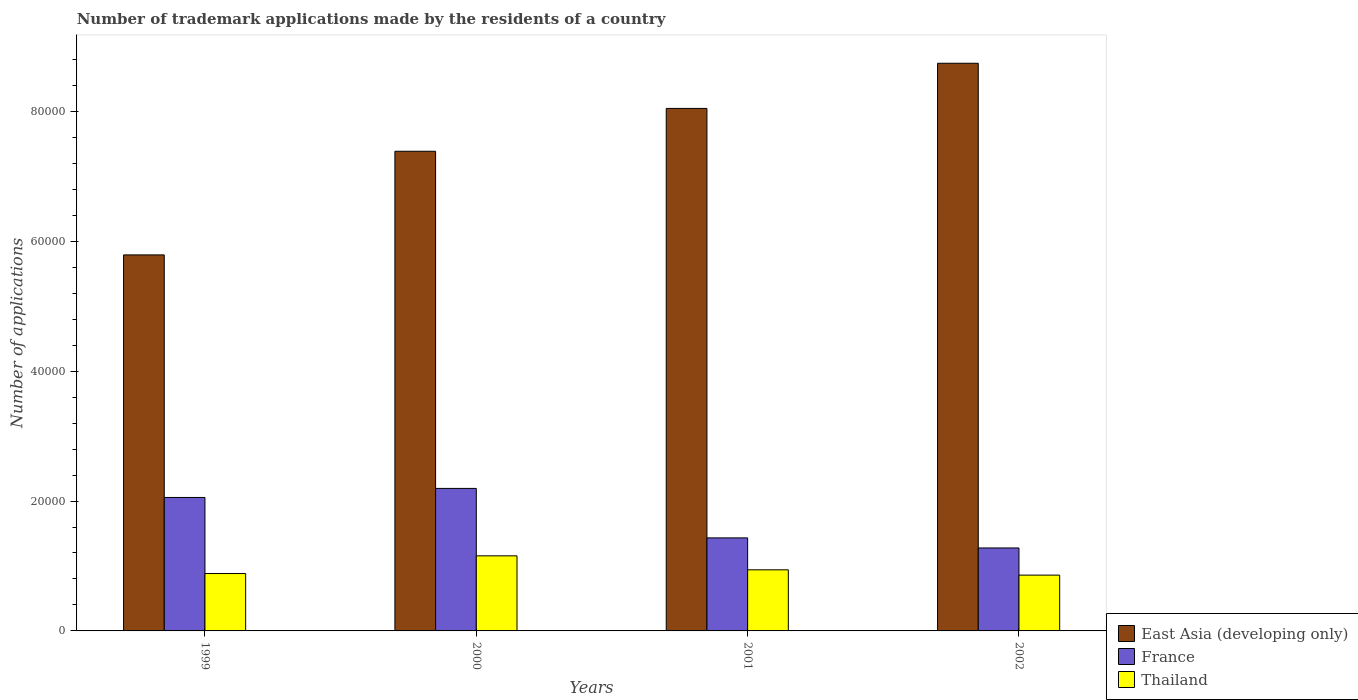How many different coloured bars are there?
Keep it short and to the point. 3. How many groups of bars are there?
Keep it short and to the point. 4. Are the number of bars per tick equal to the number of legend labels?
Ensure brevity in your answer.  Yes. How many bars are there on the 4th tick from the left?
Your answer should be very brief. 3. What is the number of trademark applications made by the residents in East Asia (developing only) in 2002?
Keep it short and to the point. 8.74e+04. Across all years, what is the maximum number of trademark applications made by the residents in East Asia (developing only)?
Offer a terse response. 8.74e+04. Across all years, what is the minimum number of trademark applications made by the residents in Thailand?
Keep it short and to the point. 8591. In which year was the number of trademark applications made by the residents in France maximum?
Offer a terse response. 2000. In which year was the number of trademark applications made by the residents in France minimum?
Ensure brevity in your answer.  2002. What is the total number of trademark applications made by the residents in France in the graph?
Your answer should be very brief. 6.96e+04. What is the difference between the number of trademark applications made by the residents in France in 1999 and that in 2001?
Ensure brevity in your answer.  6226. What is the difference between the number of trademark applications made by the residents in East Asia (developing only) in 2001 and the number of trademark applications made by the residents in France in 2002?
Your response must be concise. 6.77e+04. What is the average number of trademark applications made by the residents in Thailand per year?
Ensure brevity in your answer.  9599. In the year 2000, what is the difference between the number of trademark applications made by the residents in France and number of trademark applications made by the residents in Thailand?
Provide a short and direct response. 1.04e+04. What is the ratio of the number of trademark applications made by the residents in France in 2000 to that in 2002?
Your answer should be compact. 1.72. Is the number of trademark applications made by the residents in East Asia (developing only) in 1999 less than that in 2000?
Give a very brief answer. Yes. What is the difference between the highest and the second highest number of trademark applications made by the residents in France?
Offer a terse response. 1392. What is the difference between the highest and the lowest number of trademark applications made by the residents in East Asia (developing only)?
Give a very brief answer. 2.95e+04. In how many years, is the number of trademark applications made by the residents in Thailand greater than the average number of trademark applications made by the residents in Thailand taken over all years?
Ensure brevity in your answer.  1. Is the sum of the number of trademark applications made by the residents in France in 1999 and 2000 greater than the maximum number of trademark applications made by the residents in Thailand across all years?
Keep it short and to the point. Yes. What does the 1st bar from the left in 2002 represents?
Provide a short and direct response. East Asia (developing only). What does the 3rd bar from the right in 2002 represents?
Offer a very short reply. East Asia (developing only). How many bars are there?
Offer a very short reply. 12. Are all the bars in the graph horizontal?
Keep it short and to the point. No. How many years are there in the graph?
Provide a short and direct response. 4. How are the legend labels stacked?
Keep it short and to the point. Vertical. What is the title of the graph?
Give a very brief answer. Number of trademark applications made by the residents of a country. What is the label or title of the Y-axis?
Your answer should be compact. Number of applications. What is the Number of applications of East Asia (developing only) in 1999?
Offer a terse response. 5.79e+04. What is the Number of applications in France in 1999?
Give a very brief answer. 2.06e+04. What is the Number of applications in Thailand in 1999?
Give a very brief answer. 8838. What is the Number of applications of East Asia (developing only) in 2000?
Your response must be concise. 7.39e+04. What is the Number of applications of France in 2000?
Provide a succinct answer. 2.19e+04. What is the Number of applications of Thailand in 2000?
Offer a very short reply. 1.16e+04. What is the Number of applications of East Asia (developing only) in 2001?
Your response must be concise. 8.05e+04. What is the Number of applications of France in 2001?
Provide a short and direct response. 1.43e+04. What is the Number of applications of Thailand in 2001?
Keep it short and to the point. 9407. What is the Number of applications of East Asia (developing only) in 2002?
Provide a succinct answer. 8.74e+04. What is the Number of applications of France in 2002?
Provide a succinct answer. 1.28e+04. What is the Number of applications of Thailand in 2002?
Keep it short and to the point. 8591. Across all years, what is the maximum Number of applications of East Asia (developing only)?
Provide a short and direct response. 8.74e+04. Across all years, what is the maximum Number of applications in France?
Offer a terse response. 2.19e+04. Across all years, what is the maximum Number of applications of Thailand?
Offer a terse response. 1.16e+04. Across all years, what is the minimum Number of applications of East Asia (developing only)?
Provide a short and direct response. 5.79e+04. Across all years, what is the minimum Number of applications in France?
Offer a very short reply. 1.28e+04. Across all years, what is the minimum Number of applications in Thailand?
Your answer should be compact. 8591. What is the total Number of applications in East Asia (developing only) in the graph?
Your answer should be very brief. 3.00e+05. What is the total Number of applications of France in the graph?
Provide a succinct answer. 6.96e+04. What is the total Number of applications in Thailand in the graph?
Make the answer very short. 3.84e+04. What is the difference between the Number of applications of East Asia (developing only) in 1999 and that in 2000?
Keep it short and to the point. -1.60e+04. What is the difference between the Number of applications in France in 1999 and that in 2000?
Offer a terse response. -1392. What is the difference between the Number of applications in Thailand in 1999 and that in 2000?
Offer a very short reply. -2722. What is the difference between the Number of applications of East Asia (developing only) in 1999 and that in 2001?
Offer a very short reply. -2.26e+04. What is the difference between the Number of applications of France in 1999 and that in 2001?
Provide a succinct answer. 6226. What is the difference between the Number of applications in Thailand in 1999 and that in 2001?
Ensure brevity in your answer.  -569. What is the difference between the Number of applications in East Asia (developing only) in 1999 and that in 2002?
Keep it short and to the point. -2.95e+04. What is the difference between the Number of applications in France in 1999 and that in 2002?
Make the answer very short. 7776. What is the difference between the Number of applications of Thailand in 1999 and that in 2002?
Your response must be concise. 247. What is the difference between the Number of applications of East Asia (developing only) in 2000 and that in 2001?
Provide a succinct answer. -6597. What is the difference between the Number of applications of France in 2000 and that in 2001?
Keep it short and to the point. 7618. What is the difference between the Number of applications of Thailand in 2000 and that in 2001?
Ensure brevity in your answer.  2153. What is the difference between the Number of applications of East Asia (developing only) in 2000 and that in 2002?
Your answer should be very brief. -1.35e+04. What is the difference between the Number of applications of France in 2000 and that in 2002?
Provide a short and direct response. 9168. What is the difference between the Number of applications in Thailand in 2000 and that in 2002?
Your answer should be compact. 2969. What is the difference between the Number of applications in East Asia (developing only) in 2001 and that in 2002?
Your answer should be compact. -6952. What is the difference between the Number of applications of France in 2001 and that in 2002?
Ensure brevity in your answer.  1550. What is the difference between the Number of applications in Thailand in 2001 and that in 2002?
Your answer should be compact. 816. What is the difference between the Number of applications in East Asia (developing only) in 1999 and the Number of applications in France in 2000?
Provide a short and direct response. 3.60e+04. What is the difference between the Number of applications in East Asia (developing only) in 1999 and the Number of applications in Thailand in 2000?
Your response must be concise. 4.63e+04. What is the difference between the Number of applications in France in 1999 and the Number of applications in Thailand in 2000?
Offer a very short reply. 8990. What is the difference between the Number of applications of East Asia (developing only) in 1999 and the Number of applications of France in 2001?
Provide a short and direct response. 4.36e+04. What is the difference between the Number of applications of East Asia (developing only) in 1999 and the Number of applications of Thailand in 2001?
Your response must be concise. 4.85e+04. What is the difference between the Number of applications in France in 1999 and the Number of applications in Thailand in 2001?
Give a very brief answer. 1.11e+04. What is the difference between the Number of applications of East Asia (developing only) in 1999 and the Number of applications of France in 2002?
Provide a short and direct response. 4.51e+04. What is the difference between the Number of applications in East Asia (developing only) in 1999 and the Number of applications in Thailand in 2002?
Make the answer very short. 4.93e+04. What is the difference between the Number of applications of France in 1999 and the Number of applications of Thailand in 2002?
Your answer should be very brief. 1.20e+04. What is the difference between the Number of applications of East Asia (developing only) in 2000 and the Number of applications of France in 2001?
Provide a succinct answer. 5.95e+04. What is the difference between the Number of applications in East Asia (developing only) in 2000 and the Number of applications in Thailand in 2001?
Offer a terse response. 6.44e+04. What is the difference between the Number of applications of France in 2000 and the Number of applications of Thailand in 2001?
Your response must be concise. 1.25e+04. What is the difference between the Number of applications in East Asia (developing only) in 2000 and the Number of applications in France in 2002?
Your answer should be very brief. 6.11e+04. What is the difference between the Number of applications in East Asia (developing only) in 2000 and the Number of applications in Thailand in 2002?
Your response must be concise. 6.53e+04. What is the difference between the Number of applications of France in 2000 and the Number of applications of Thailand in 2002?
Keep it short and to the point. 1.34e+04. What is the difference between the Number of applications of East Asia (developing only) in 2001 and the Number of applications of France in 2002?
Your answer should be very brief. 6.77e+04. What is the difference between the Number of applications of East Asia (developing only) in 2001 and the Number of applications of Thailand in 2002?
Offer a terse response. 7.19e+04. What is the difference between the Number of applications in France in 2001 and the Number of applications in Thailand in 2002?
Provide a succinct answer. 5733. What is the average Number of applications in East Asia (developing only) per year?
Your answer should be compact. 7.49e+04. What is the average Number of applications in France per year?
Offer a terse response. 1.74e+04. What is the average Number of applications in Thailand per year?
Your answer should be very brief. 9599. In the year 1999, what is the difference between the Number of applications of East Asia (developing only) and Number of applications of France?
Provide a short and direct response. 3.73e+04. In the year 1999, what is the difference between the Number of applications of East Asia (developing only) and Number of applications of Thailand?
Ensure brevity in your answer.  4.91e+04. In the year 1999, what is the difference between the Number of applications of France and Number of applications of Thailand?
Ensure brevity in your answer.  1.17e+04. In the year 2000, what is the difference between the Number of applications in East Asia (developing only) and Number of applications in France?
Your answer should be compact. 5.19e+04. In the year 2000, what is the difference between the Number of applications of East Asia (developing only) and Number of applications of Thailand?
Your answer should be very brief. 6.23e+04. In the year 2000, what is the difference between the Number of applications of France and Number of applications of Thailand?
Give a very brief answer. 1.04e+04. In the year 2001, what is the difference between the Number of applications of East Asia (developing only) and Number of applications of France?
Your response must be concise. 6.61e+04. In the year 2001, what is the difference between the Number of applications in East Asia (developing only) and Number of applications in Thailand?
Provide a short and direct response. 7.10e+04. In the year 2001, what is the difference between the Number of applications in France and Number of applications in Thailand?
Provide a short and direct response. 4917. In the year 2002, what is the difference between the Number of applications in East Asia (developing only) and Number of applications in France?
Your answer should be compact. 7.46e+04. In the year 2002, what is the difference between the Number of applications of East Asia (developing only) and Number of applications of Thailand?
Your response must be concise. 7.88e+04. In the year 2002, what is the difference between the Number of applications in France and Number of applications in Thailand?
Give a very brief answer. 4183. What is the ratio of the Number of applications in East Asia (developing only) in 1999 to that in 2000?
Ensure brevity in your answer.  0.78. What is the ratio of the Number of applications in France in 1999 to that in 2000?
Your answer should be compact. 0.94. What is the ratio of the Number of applications of Thailand in 1999 to that in 2000?
Offer a very short reply. 0.76. What is the ratio of the Number of applications in East Asia (developing only) in 1999 to that in 2001?
Ensure brevity in your answer.  0.72. What is the ratio of the Number of applications of France in 1999 to that in 2001?
Make the answer very short. 1.43. What is the ratio of the Number of applications of Thailand in 1999 to that in 2001?
Offer a terse response. 0.94. What is the ratio of the Number of applications in East Asia (developing only) in 1999 to that in 2002?
Your answer should be compact. 0.66. What is the ratio of the Number of applications in France in 1999 to that in 2002?
Provide a succinct answer. 1.61. What is the ratio of the Number of applications of Thailand in 1999 to that in 2002?
Offer a very short reply. 1.03. What is the ratio of the Number of applications of East Asia (developing only) in 2000 to that in 2001?
Keep it short and to the point. 0.92. What is the ratio of the Number of applications in France in 2000 to that in 2001?
Your answer should be compact. 1.53. What is the ratio of the Number of applications of Thailand in 2000 to that in 2001?
Provide a succinct answer. 1.23. What is the ratio of the Number of applications in East Asia (developing only) in 2000 to that in 2002?
Provide a succinct answer. 0.84. What is the ratio of the Number of applications of France in 2000 to that in 2002?
Provide a succinct answer. 1.72. What is the ratio of the Number of applications in Thailand in 2000 to that in 2002?
Offer a terse response. 1.35. What is the ratio of the Number of applications in East Asia (developing only) in 2001 to that in 2002?
Your answer should be compact. 0.92. What is the ratio of the Number of applications of France in 2001 to that in 2002?
Give a very brief answer. 1.12. What is the ratio of the Number of applications of Thailand in 2001 to that in 2002?
Make the answer very short. 1.09. What is the difference between the highest and the second highest Number of applications of East Asia (developing only)?
Give a very brief answer. 6952. What is the difference between the highest and the second highest Number of applications of France?
Offer a very short reply. 1392. What is the difference between the highest and the second highest Number of applications of Thailand?
Make the answer very short. 2153. What is the difference between the highest and the lowest Number of applications in East Asia (developing only)?
Provide a succinct answer. 2.95e+04. What is the difference between the highest and the lowest Number of applications in France?
Make the answer very short. 9168. What is the difference between the highest and the lowest Number of applications of Thailand?
Offer a terse response. 2969. 